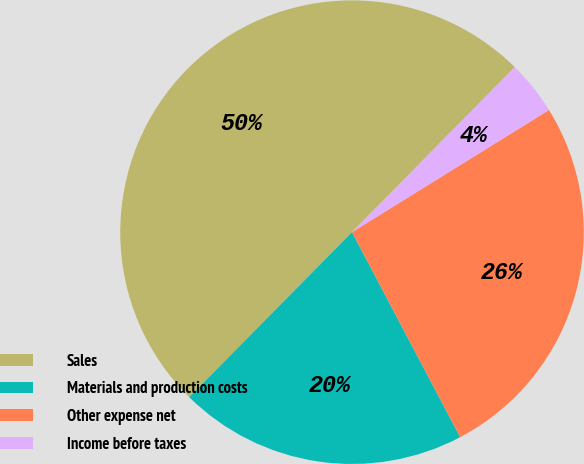Convert chart to OTSL. <chart><loc_0><loc_0><loc_500><loc_500><pie_chart><fcel>Sales<fcel>Materials and production costs<fcel>Other expense net<fcel>Income before taxes<nl><fcel>50.0%<fcel>20.12%<fcel>26.11%<fcel>3.77%<nl></chart> 